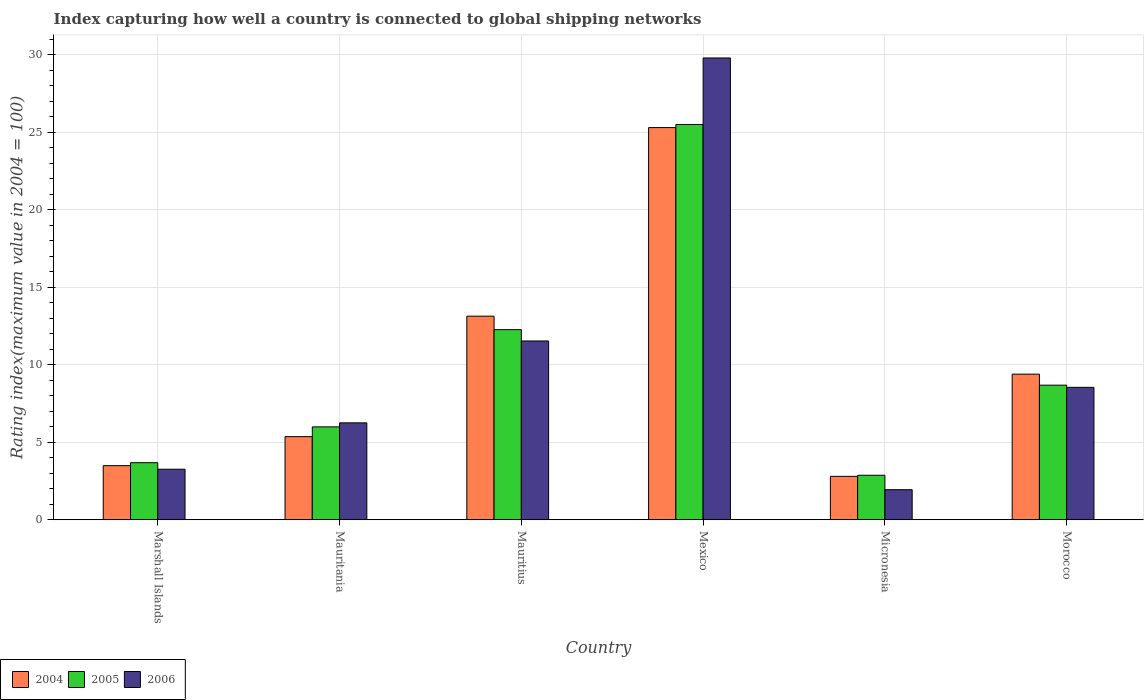How many groups of bars are there?
Make the answer very short. 6. Are the number of bars on each tick of the X-axis equal?
Make the answer very short. Yes. What is the label of the 6th group of bars from the left?
Offer a very short reply. Morocco. In how many cases, is the number of bars for a given country not equal to the number of legend labels?
Your answer should be compact. 0. What is the rating index in 2004 in Mauritania?
Your answer should be compact. 5.36. Across all countries, what is the maximum rating index in 2005?
Make the answer very short. 25.49. Across all countries, what is the minimum rating index in 2005?
Your answer should be compact. 2.87. In which country was the rating index in 2004 maximum?
Give a very brief answer. Mexico. In which country was the rating index in 2006 minimum?
Your answer should be compact. Micronesia. What is the total rating index in 2005 in the graph?
Your response must be concise. 58.97. What is the difference between the rating index in 2006 in Mexico and that in Morocco?
Ensure brevity in your answer.  21.24. What is the difference between the rating index in 2006 in Morocco and the rating index in 2004 in Micronesia?
Keep it short and to the point. 5.74. What is the average rating index in 2004 per country?
Keep it short and to the point. 9.91. What is the difference between the rating index of/in 2004 and rating index of/in 2006 in Micronesia?
Your answer should be very brief. 0.86. What is the ratio of the rating index in 2006 in Micronesia to that in Morocco?
Provide a succinct answer. 0.23. Is the rating index in 2005 in Mauritius less than that in Morocco?
Keep it short and to the point. No. Is the difference between the rating index in 2004 in Mauritania and Morocco greater than the difference between the rating index in 2006 in Mauritania and Morocco?
Ensure brevity in your answer.  No. What is the difference between the highest and the second highest rating index in 2004?
Keep it short and to the point. 12.16. What is the difference between the highest and the lowest rating index in 2004?
Make the answer very short. 22.49. In how many countries, is the rating index in 2004 greater than the average rating index in 2004 taken over all countries?
Ensure brevity in your answer.  2. Is the sum of the rating index in 2004 in Marshall Islands and Morocco greater than the maximum rating index in 2005 across all countries?
Make the answer very short. No. What does the 3rd bar from the left in Morocco represents?
Provide a succinct answer. 2006. What does the 3rd bar from the right in Mauritania represents?
Offer a very short reply. 2004. How many bars are there?
Offer a terse response. 18. What is the difference between two consecutive major ticks on the Y-axis?
Make the answer very short. 5. Does the graph contain grids?
Your response must be concise. Yes. How many legend labels are there?
Your answer should be compact. 3. What is the title of the graph?
Offer a terse response. Index capturing how well a country is connected to global shipping networks. What is the label or title of the Y-axis?
Give a very brief answer. Rating index(maximum value in 2004 = 100). What is the Rating index(maximum value in 2004 = 100) of 2004 in Marshall Islands?
Your answer should be compact. 3.49. What is the Rating index(maximum value in 2004 = 100) in 2005 in Marshall Islands?
Make the answer very short. 3.68. What is the Rating index(maximum value in 2004 = 100) in 2006 in Marshall Islands?
Provide a short and direct response. 3.26. What is the Rating index(maximum value in 2004 = 100) in 2004 in Mauritania?
Your response must be concise. 5.36. What is the Rating index(maximum value in 2004 = 100) in 2005 in Mauritania?
Ensure brevity in your answer.  5.99. What is the Rating index(maximum value in 2004 = 100) in 2006 in Mauritania?
Provide a succinct answer. 6.25. What is the Rating index(maximum value in 2004 = 100) of 2004 in Mauritius?
Your answer should be compact. 13.13. What is the Rating index(maximum value in 2004 = 100) of 2005 in Mauritius?
Your answer should be compact. 12.26. What is the Rating index(maximum value in 2004 = 100) in 2006 in Mauritius?
Your answer should be very brief. 11.53. What is the Rating index(maximum value in 2004 = 100) of 2004 in Mexico?
Your answer should be very brief. 25.29. What is the Rating index(maximum value in 2004 = 100) in 2005 in Mexico?
Ensure brevity in your answer.  25.49. What is the Rating index(maximum value in 2004 = 100) of 2006 in Mexico?
Provide a short and direct response. 29.78. What is the Rating index(maximum value in 2004 = 100) of 2005 in Micronesia?
Keep it short and to the point. 2.87. What is the Rating index(maximum value in 2004 = 100) of 2006 in Micronesia?
Your answer should be very brief. 1.94. What is the Rating index(maximum value in 2004 = 100) of 2004 in Morocco?
Ensure brevity in your answer.  9.39. What is the Rating index(maximum value in 2004 = 100) of 2005 in Morocco?
Provide a short and direct response. 8.68. What is the Rating index(maximum value in 2004 = 100) of 2006 in Morocco?
Your answer should be compact. 8.54. Across all countries, what is the maximum Rating index(maximum value in 2004 = 100) in 2004?
Give a very brief answer. 25.29. Across all countries, what is the maximum Rating index(maximum value in 2004 = 100) of 2005?
Your answer should be compact. 25.49. Across all countries, what is the maximum Rating index(maximum value in 2004 = 100) in 2006?
Offer a very short reply. 29.78. Across all countries, what is the minimum Rating index(maximum value in 2004 = 100) in 2004?
Keep it short and to the point. 2.8. Across all countries, what is the minimum Rating index(maximum value in 2004 = 100) in 2005?
Make the answer very short. 2.87. Across all countries, what is the minimum Rating index(maximum value in 2004 = 100) of 2006?
Provide a short and direct response. 1.94. What is the total Rating index(maximum value in 2004 = 100) of 2004 in the graph?
Your response must be concise. 59.46. What is the total Rating index(maximum value in 2004 = 100) of 2005 in the graph?
Give a very brief answer. 58.97. What is the total Rating index(maximum value in 2004 = 100) in 2006 in the graph?
Make the answer very short. 61.3. What is the difference between the Rating index(maximum value in 2004 = 100) of 2004 in Marshall Islands and that in Mauritania?
Your response must be concise. -1.87. What is the difference between the Rating index(maximum value in 2004 = 100) in 2005 in Marshall Islands and that in Mauritania?
Ensure brevity in your answer.  -2.31. What is the difference between the Rating index(maximum value in 2004 = 100) in 2006 in Marshall Islands and that in Mauritania?
Ensure brevity in your answer.  -2.99. What is the difference between the Rating index(maximum value in 2004 = 100) of 2004 in Marshall Islands and that in Mauritius?
Your answer should be very brief. -9.64. What is the difference between the Rating index(maximum value in 2004 = 100) in 2005 in Marshall Islands and that in Mauritius?
Offer a terse response. -8.58. What is the difference between the Rating index(maximum value in 2004 = 100) in 2006 in Marshall Islands and that in Mauritius?
Offer a terse response. -8.27. What is the difference between the Rating index(maximum value in 2004 = 100) of 2004 in Marshall Islands and that in Mexico?
Provide a succinct answer. -21.8. What is the difference between the Rating index(maximum value in 2004 = 100) in 2005 in Marshall Islands and that in Mexico?
Provide a short and direct response. -21.81. What is the difference between the Rating index(maximum value in 2004 = 100) of 2006 in Marshall Islands and that in Mexico?
Offer a terse response. -26.52. What is the difference between the Rating index(maximum value in 2004 = 100) of 2004 in Marshall Islands and that in Micronesia?
Offer a terse response. 0.69. What is the difference between the Rating index(maximum value in 2004 = 100) in 2005 in Marshall Islands and that in Micronesia?
Provide a short and direct response. 0.81. What is the difference between the Rating index(maximum value in 2004 = 100) of 2006 in Marshall Islands and that in Micronesia?
Your answer should be compact. 1.32. What is the difference between the Rating index(maximum value in 2004 = 100) of 2006 in Marshall Islands and that in Morocco?
Provide a short and direct response. -5.28. What is the difference between the Rating index(maximum value in 2004 = 100) of 2004 in Mauritania and that in Mauritius?
Offer a very short reply. -7.77. What is the difference between the Rating index(maximum value in 2004 = 100) in 2005 in Mauritania and that in Mauritius?
Give a very brief answer. -6.27. What is the difference between the Rating index(maximum value in 2004 = 100) of 2006 in Mauritania and that in Mauritius?
Offer a very short reply. -5.28. What is the difference between the Rating index(maximum value in 2004 = 100) in 2004 in Mauritania and that in Mexico?
Your response must be concise. -19.93. What is the difference between the Rating index(maximum value in 2004 = 100) in 2005 in Mauritania and that in Mexico?
Give a very brief answer. -19.5. What is the difference between the Rating index(maximum value in 2004 = 100) of 2006 in Mauritania and that in Mexico?
Provide a short and direct response. -23.53. What is the difference between the Rating index(maximum value in 2004 = 100) in 2004 in Mauritania and that in Micronesia?
Ensure brevity in your answer.  2.56. What is the difference between the Rating index(maximum value in 2004 = 100) of 2005 in Mauritania and that in Micronesia?
Provide a succinct answer. 3.12. What is the difference between the Rating index(maximum value in 2004 = 100) in 2006 in Mauritania and that in Micronesia?
Provide a short and direct response. 4.31. What is the difference between the Rating index(maximum value in 2004 = 100) in 2004 in Mauritania and that in Morocco?
Ensure brevity in your answer.  -4.03. What is the difference between the Rating index(maximum value in 2004 = 100) in 2005 in Mauritania and that in Morocco?
Offer a very short reply. -2.69. What is the difference between the Rating index(maximum value in 2004 = 100) in 2006 in Mauritania and that in Morocco?
Make the answer very short. -2.29. What is the difference between the Rating index(maximum value in 2004 = 100) of 2004 in Mauritius and that in Mexico?
Your answer should be compact. -12.16. What is the difference between the Rating index(maximum value in 2004 = 100) in 2005 in Mauritius and that in Mexico?
Ensure brevity in your answer.  -13.23. What is the difference between the Rating index(maximum value in 2004 = 100) of 2006 in Mauritius and that in Mexico?
Your response must be concise. -18.25. What is the difference between the Rating index(maximum value in 2004 = 100) in 2004 in Mauritius and that in Micronesia?
Offer a very short reply. 10.33. What is the difference between the Rating index(maximum value in 2004 = 100) in 2005 in Mauritius and that in Micronesia?
Provide a succinct answer. 9.39. What is the difference between the Rating index(maximum value in 2004 = 100) in 2006 in Mauritius and that in Micronesia?
Offer a terse response. 9.59. What is the difference between the Rating index(maximum value in 2004 = 100) of 2004 in Mauritius and that in Morocco?
Provide a succinct answer. 3.74. What is the difference between the Rating index(maximum value in 2004 = 100) of 2005 in Mauritius and that in Morocco?
Your response must be concise. 3.58. What is the difference between the Rating index(maximum value in 2004 = 100) of 2006 in Mauritius and that in Morocco?
Offer a terse response. 2.99. What is the difference between the Rating index(maximum value in 2004 = 100) of 2004 in Mexico and that in Micronesia?
Provide a short and direct response. 22.49. What is the difference between the Rating index(maximum value in 2004 = 100) in 2005 in Mexico and that in Micronesia?
Offer a very short reply. 22.62. What is the difference between the Rating index(maximum value in 2004 = 100) in 2006 in Mexico and that in Micronesia?
Your response must be concise. 27.84. What is the difference between the Rating index(maximum value in 2004 = 100) in 2004 in Mexico and that in Morocco?
Your answer should be compact. 15.9. What is the difference between the Rating index(maximum value in 2004 = 100) of 2005 in Mexico and that in Morocco?
Your answer should be compact. 16.81. What is the difference between the Rating index(maximum value in 2004 = 100) of 2006 in Mexico and that in Morocco?
Provide a succinct answer. 21.24. What is the difference between the Rating index(maximum value in 2004 = 100) of 2004 in Micronesia and that in Morocco?
Make the answer very short. -6.59. What is the difference between the Rating index(maximum value in 2004 = 100) of 2005 in Micronesia and that in Morocco?
Make the answer very short. -5.81. What is the difference between the Rating index(maximum value in 2004 = 100) of 2004 in Marshall Islands and the Rating index(maximum value in 2004 = 100) of 2005 in Mauritania?
Your response must be concise. -2.5. What is the difference between the Rating index(maximum value in 2004 = 100) of 2004 in Marshall Islands and the Rating index(maximum value in 2004 = 100) of 2006 in Mauritania?
Offer a terse response. -2.76. What is the difference between the Rating index(maximum value in 2004 = 100) of 2005 in Marshall Islands and the Rating index(maximum value in 2004 = 100) of 2006 in Mauritania?
Keep it short and to the point. -2.57. What is the difference between the Rating index(maximum value in 2004 = 100) in 2004 in Marshall Islands and the Rating index(maximum value in 2004 = 100) in 2005 in Mauritius?
Provide a short and direct response. -8.77. What is the difference between the Rating index(maximum value in 2004 = 100) in 2004 in Marshall Islands and the Rating index(maximum value in 2004 = 100) in 2006 in Mauritius?
Your response must be concise. -8.04. What is the difference between the Rating index(maximum value in 2004 = 100) in 2005 in Marshall Islands and the Rating index(maximum value in 2004 = 100) in 2006 in Mauritius?
Make the answer very short. -7.85. What is the difference between the Rating index(maximum value in 2004 = 100) in 2004 in Marshall Islands and the Rating index(maximum value in 2004 = 100) in 2006 in Mexico?
Ensure brevity in your answer.  -26.29. What is the difference between the Rating index(maximum value in 2004 = 100) of 2005 in Marshall Islands and the Rating index(maximum value in 2004 = 100) of 2006 in Mexico?
Ensure brevity in your answer.  -26.1. What is the difference between the Rating index(maximum value in 2004 = 100) of 2004 in Marshall Islands and the Rating index(maximum value in 2004 = 100) of 2005 in Micronesia?
Offer a terse response. 0.62. What is the difference between the Rating index(maximum value in 2004 = 100) of 2004 in Marshall Islands and the Rating index(maximum value in 2004 = 100) of 2006 in Micronesia?
Your response must be concise. 1.55. What is the difference between the Rating index(maximum value in 2004 = 100) in 2005 in Marshall Islands and the Rating index(maximum value in 2004 = 100) in 2006 in Micronesia?
Your answer should be very brief. 1.74. What is the difference between the Rating index(maximum value in 2004 = 100) in 2004 in Marshall Islands and the Rating index(maximum value in 2004 = 100) in 2005 in Morocco?
Provide a succinct answer. -5.19. What is the difference between the Rating index(maximum value in 2004 = 100) of 2004 in Marshall Islands and the Rating index(maximum value in 2004 = 100) of 2006 in Morocco?
Ensure brevity in your answer.  -5.05. What is the difference between the Rating index(maximum value in 2004 = 100) of 2005 in Marshall Islands and the Rating index(maximum value in 2004 = 100) of 2006 in Morocco?
Ensure brevity in your answer.  -4.86. What is the difference between the Rating index(maximum value in 2004 = 100) of 2004 in Mauritania and the Rating index(maximum value in 2004 = 100) of 2005 in Mauritius?
Your answer should be compact. -6.9. What is the difference between the Rating index(maximum value in 2004 = 100) of 2004 in Mauritania and the Rating index(maximum value in 2004 = 100) of 2006 in Mauritius?
Ensure brevity in your answer.  -6.17. What is the difference between the Rating index(maximum value in 2004 = 100) of 2005 in Mauritania and the Rating index(maximum value in 2004 = 100) of 2006 in Mauritius?
Provide a succinct answer. -5.54. What is the difference between the Rating index(maximum value in 2004 = 100) of 2004 in Mauritania and the Rating index(maximum value in 2004 = 100) of 2005 in Mexico?
Give a very brief answer. -20.13. What is the difference between the Rating index(maximum value in 2004 = 100) in 2004 in Mauritania and the Rating index(maximum value in 2004 = 100) in 2006 in Mexico?
Give a very brief answer. -24.42. What is the difference between the Rating index(maximum value in 2004 = 100) of 2005 in Mauritania and the Rating index(maximum value in 2004 = 100) of 2006 in Mexico?
Ensure brevity in your answer.  -23.79. What is the difference between the Rating index(maximum value in 2004 = 100) in 2004 in Mauritania and the Rating index(maximum value in 2004 = 100) in 2005 in Micronesia?
Offer a very short reply. 2.49. What is the difference between the Rating index(maximum value in 2004 = 100) in 2004 in Mauritania and the Rating index(maximum value in 2004 = 100) in 2006 in Micronesia?
Make the answer very short. 3.42. What is the difference between the Rating index(maximum value in 2004 = 100) in 2005 in Mauritania and the Rating index(maximum value in 2004 = 100) in 2006 in Micronesia?
Provide a succinct answer. 4.05. What is the difference between the Rating index(maximum value in 2004 = 100) of 2004 in Mauritania and the Rating index(maximum value in 2004 = 100) of 2005 in Morocco?
Your answer should be very brief. -3.32. What is the difference between the Rating index(maximum value in 2004 = 100) in 2004 in Mauritania and the Rating index(maximum value in 2004 = 100) in 2006 in Morocco?
Offer a terse response. -3.18. What is the difference between the Rating index(maximum value in 2004 = 100) of 2005 in Mauritania and the Rating index(maximum value in 2004 = 100) of 2006 in Morocco?
Your answer should be compact. -2.55. What is the difference between the Rating index(maximum value in 2004 = 100) in 2004 in Mauritius and the Rating index(maximum value in 2004 = 100) in 2005 in Mexico?
Your answer should be compact. -12.36. What is the difference between the Rating index(maximum value in 2004 = 100) in 2004 in Mauritius and the Rating index(maximum value in 2004 = 100) in 2006 in Mexico?
Offer a terse response. -16.65. What is the difference between the Rating index(maximum value in 2004 = 100) of 2005 in Mauritius and the Rating index(maximum value in 2004 = 100) of 2006 in Mexico?
Provide a short and direct response. -17.52. What is the difference between the Rating index(maximum value in 2004 = 100) of 2004 in Mauritius and the Rating index(maximum value in 2004 = 100) of 2005 in Micronesia?
Give a very brief answer. 10.26. What is the difference between the Rating index(maximum value in 2004 = 100) of 2004 in Mauritius and the Rating index(maximum value in 2004 = 100) of 2006 in Micronesia?
Keep it short and to the point. 11.19. What is the difference between the Rating index(maximum value in 2004 = 100) of 2005 in Mauritius and the Rating index(maximum value in 2004 = 100) of 2006 in Micronesia?
Keep it short and to the point. 10.32. What is the difference between the Rating index(maximum value in 2004 = 100) of 2004 in Mauritius and the Rating index(maximum value in 2004 = 100) of 2005 in Morocco?
Make the answer very short. 4.45. What is the difference between the Rating index(maximum value in 2004 = 100) in 2004 in Mauritius and the Rating index(maximum value in 2004 = 100) in 2006 in Morocco?
Ensure brevity in your answer.  4.59. What is the difference between the Rating index(maximum value in 2004 = 100) in 2005 in Mauritius and the Rating index(maximum value in 2004 = 100) in 2006 in Morocco?
Offer a terse response. 3.72. What is the difference between the Rating index(maximum value in 2004 = 100) in 2004 in Mexico and the Rating index(maximum value in 2004 = 100) in 2005 in Micronesia?
Provide a succinct answer. 22.42. What is the difference between the Rating index(maximum value in 2004 = 100) in 2004 in Mexico and the Rating index(maximum value in 2004 = 100) in 2006 in Micronesia?
Your answer should be compact. 23.35. What is the difference between the Rating index(maximum value in 2004 = 100) of 2005 in Mexico and the Rating index(maximum value in 2004 = 100) of 2006 in Micronesia?
Ensure brevity in your answer.  23.55. What is the difference between the Rating index(maximum value in 2004 = 100) of 2004 in Mexico and the Rating index(maximum value in 2004 = 100) of 2005 in Morocco?
Offer a very short reply. 16.61. What is the difference between the Rating index(maximum value in 2004 = 100) in 2004 in Mexico and the Rating index(maximum value in 2004 = 100) in 2006 in Morocco?
Your answer should be compact. 16.75. What is the difference between the Rating index(maximum value in 2004 = 100) of 2005 in Mexico and the Rating index(maximum value in 2004 = 100) of 2006 in Morocco?
Your response must be concise. 16.95. What is the difference between the Rating index(maximum value in 2004 = 100) in 2004 in Micronesia and the Rating index(maximum value in 2004 = 100) in 2005 in Morocco?
Offer a terse response. -5.88. What is the difference between the Rating index(maximum value in 2004 = 100) of 2004 in Micronesia and the Rating index(maximum value in 2004 = 100) of 2006 in Morocco?
Your answer should be very brief. -5.74. What is the difference between the Rating index(maximum value in 2004 = 100) of 2005 in Micronesia and the Rating index(maximum value in 2004 = 100) of 2006 in Morocco?
Give a very brief answer. -5.67. What is the average Rating index(maximum value in 2004 = 100) in 2004 per country?
Offer a very short reply. 9.91. What is the average Rating index(maximum value in 2004 = 100) in 2005 per country?
Make the answer very short. 9.83. What is the average Rating index(maximum value in 2004 = 100) in 2006 per country?
Keep it short and to the point. 10.22. What is the difference between the Rating index(maximum value in 2004 = 100) of 2004 and Rating index(maximum value in 2004 = 100) of 2005 in Marshall Islands?
Ensure brevity in your answer.  -0.19. What is the difference between the Rating index(maximum value in 2004 = 100) in 2004 and Rating index(maximum value in 2004 = 100) in 2006 in Marshall Islands?
Provide a succinct answer. 0.23. What is the difference between the Rating index(maximum value in 2004 = 100) of 2005 and Rating index(maximum value in 2004 = 100) of 2006 in Marshall Islands?
Your answer should be compact. 0.42. What is the difference between the Rating index(maximum value in 2004 = 100) in 2004 and Rating index(maximum value in 2004 = 100) in 2005 in Mauritania?
Ensure brevity in your answer.  -0.63. What is the difference between the Rating index(maximum value in 2004 = 100) in 2004 and Rating index(maximum value in 2004 = 100) in 2006 in Mauritania?
Provide a short and direct response. -0.89. What is the difference between the Rating index(maximum value in 2004 = 100) in 2005 and Rating index(maximum value in 2004 = 100) in 2006 in Mauritania?
Your answer should be very brief. -0.26. What is the difference between the Rating index(maximum value in 2004 = 100) of 2004 and Rating index(maximum value in 2004 = 100) of 2005 in Mauritius?
Your answer should be very brief. 0.87. What is the difference between the Rating index(maximum value in 2004 = 100) in 2004 and Rating index(maximum value in 2004 = 100) in 2006 in Mauritius?
Provide a short and direct response. 1.6. What is the difference between the Rating index(maximum value in 2004 = 100) of 2005 and Rating index(maximum value in 2004 = 100) of 2006 in Mauritius?
Provide a short and direct response. 0.73. What is the difference between the Rating index(maximum value in 2004 = 100) in 2004 and Rating index(maximum value in 2004 = 100) in 2006 in Mexico?
Keep it short and to the point. -4.49. What is the difference between the Rating index(maximum value in 2004 = 100) of 2005 and Rating index(maximum value in 2004 = 100) of 2006 in Mexico?
Provide a short and direct response. -4.29. What is the difference between the Rating index(maximum value in 2004 = 100) in 2004 and Rating index(maximum value in 2004 = 100) in 2005 in Micronesia?
Your answer should be very brief. -0.07. What is the difference between the Rating index(maximum value in 2004 = 100) of 2004 and Rating index(maximum value in 2004 = 100) of 2006 in Micronesia?
Provide a succinct answer. 0.86. What is the difference between the Rating index(maximum value in 2004 = 100) of 2004 and Rating index(maximum value in 2004 = 100) of 2005 in Morocco?
Offer a very short reply. 0.71. What is the difference between the Rating index(maximum value in 2004 = 100) in 2004 and Rating index(maximum value in 2004 = 100) in 2006 in Morocco?
Make the answer very short. 0.85. What is the difference between the Rating index(maximum value in 2004 = 100) in 2005 and Rating index(maximum value in 2004 = 100) in 2006 in Morocco?
Provide a short and direct response. 0.14. What is the ratio of the Rating index(maximum value in 2004 = 100) in 2004 in Marshall Islands to that in Mauritania?
Ensure brevity in your answer.  0.65. What is the ratio of the Rating index(maximum value in 2004 = 100) in 2005 in Marshall Islands to that in Mauritania?
Provide a short and direct response. 0.61. What is the ratio of the Rating index(maximum value in 2004 = 100) in 2006 in Marshall Islands to that in Mauritania?
Provide a succinct answer. 0.52. What is the ratio of the Rating index(maximum value in 2004 = 100) of 2004 in Marshall Islands to that in Mauritius?
Offer a terse response. 0.27. What is the ratio of the Rating index(maximum value in 2004 = 100) of 2005 in Marshall Islands to that in Mauritius?
Your response must be concise. 0.3. What is the ratio of the Rating index(maximum value in 2004 = 100) in 2006 in Marshall Islands to that in Mauritius?
Offer a terse response. 0.28. What is the ratio of the Rating index(maximum value in 2004 = 100) in 2004 in Marshall Islands to that in Mexico?
Give a very brief answer. 0.14. What is the ratio of the Rating index(maximum value in 2004 = 100) of 2005 in Marshall Islands to that in Mexico?
Ensure brevity in your answer.  0.14. What is the ratio of the Rating index(maximum value in 2004 = 100) in 2006 in Marshall Islands to that in Mexico?
Keep it short and to the point. 0.11. What is the ratio of the Rating index(maximum value in 2004 = 100) in 2004 in Marshall Islands to that in Micronesia?
Give a very brief answer. 1.25. What is the ratio of the Rating index(maximum value in 2004 = 100) in 2005 in Marshall Islands to that in Micronesia?
Offer a terse response. 1.28. What is the ratio of the Rating index(maximum value in 2004 = 100) in 2006 in Marshall Islands to that in Micronesia?
Ensure brevity in your answer.  1.68. What is the ratio of the Rating index(maximum value in 2004 = 100) of 2004 in Marshall Islands to that in Morocco?
Offer a terse response. 0.37. What is the ratio of the Rating index(maximum value in 2004 = 100) of 2005 in Marshall Islands to that in Morocco?
Offer a very short reply. 0.42. What is the ratio of the Rating index(maximum value in 2004 = 100) of 2006 in Marshall Islands to that in Morocco?
Make the answer very short. 0.38. What is the ratio of the Rating index(maximum value in 2004 = 100) of 2004 in Mauritania to that in Mauritius?
Your answer should be compact. 0.41. What is the ratio of the Rating index(maximum value in 2004 = 100) of 2005 in Mauritania to that in Mauritius?
Keep it short and to the point. 0.49. What is the ratio of the Rating index(maximum value in 2004 = 100) in 2006 in Mauritania to that in Mauritius?
Ensure brevity in your answer.  0.54. What is the ratio of the Rating index(maximum value in 2004 = 100) of 2004 in Mauritania to that in Mexico?
Your answer should be very brief. 0.21. What is the ratio of the Rating index(maximum value in 2004 = 100) of 2005 in Mauritania to that in Mexico?
Give a very brief answer. 0.23. What is the ratio of the Rating index(maximum value in 2004 = 100) of 2006 in Mauritania to that in Mexico?
Provide a succinct answer. 0.21. What is the ratio of the Rating index(maximum value in 2004 = 100) of 2004 in Mauritania to that in Micronesia?
Your answer should be very brief. 1.91. What is the ratio of the Rating index(maximum value in 2004 = 100) of 2005 in Mauritania to that in Micronesia?
Provide a succinct answer. 2.09. What is the ratio of the Rating index(maximum value in 2004 = 100) of 2006 in Mauritania to that in Micronesia?
Your answer should be very brief. 3.22. What is the ratio of the Rating index(maximum value in 2004 = 100) of 2004 in Mauritania to that in Morocco?
Offer a terse response. 0.57. What is the ratio of the Rating index(maximum value in 2004 = 100) of 2005 in Mauritania to that in Morocco?
Make the answer very short. 0.69. What is the ratio of the Rating index(maximum value in 2004 = 100) in 2006 in Mauritania to that in Morocco?
Keep it short and to the point. 0.73. What is the ratio of the Rating index(maximum value in 2004 = 100) of 2004 in Mauritius to that in Mexico?
Provide a succinct answer. 0.52. What is the ratio of the Rating index(maximum value in 2004 = 100) of 2005 in Mauritius to that in Mexico?
Offer a very short reply. 0.48. What is the ratio of the Rating index(maximum value in 2004 = 100) of 2006 in Mauritius to that in Mexico?
Your response must be concise. 0.39. What is the ratio of the Rating index(maximum value in 2004 = 100) in 2004 in Mauritius to that in Micronesia?
Offer a very short reply. 4.69. What is the ratio of the Rating index(maximum value in 2004 = 100) in 2005 in Mauritius to that in Micronesia?
Offer a terse response. 4.27. What is the ratio of the Rating index(maximum value in 2004 = 100) of 2006 in Mauritius to that in Micronesia?
Ensure brevity in your answer.  5.94. What is the ratio of the Rating index(maximum value in 2004 = 100) of 2004 in Mauritius to that in Morocco?
Your response must be concise. 1.4. What is the ratio of the Rating index(maximum value in 2004 = 100) of 2005 in Mauritius to that in Morocco?
Ensure brevity in your answer.  1.41. What is the ratio of the Rating index(maximum value in 2004 = 100) in 2006 in Mauritius to that in Morocco?
Provide a succinct answer. 1.35. What is the ratio of the Rating index(maximum value in 2004 = 100) in 2004 in Mexico to that in Micronesia?
Give a very brief answer. 9.03. What is the ratio of the Rating index(maximum value in 2004 = 100) in 2005 in Mexico to that in Micronesia?
Your answer should be very brief. 8.88. What is the ratio of the Rating index(maximum value in 2004 = 100) in 2006 in Mexico to that in Micronesia?
Keep it short and to the point. 15.35. What is the ratio of the Rating index(maximum value in 2004 = 100) of 2004 in Mexico to that in Morocco?
Offer a terse response. 2.69. What is the ratio of the Rating index(maximum value in 2004 = 100) in 2005 in Mexico to that in Morocco?
Offer a very short reply. 2.94. What is the ratio of the Rating index(maximum value in 2004 = 100) in 2006 in Mexico to that in Morocco?
Keep it short and to the point. 3.49. What is the ratio of the Rating index(maximum value in 2004 = 100) in 2004 in Micronesia to that in Morocco?
Your answer should be very brief. 0.3. What is the ratio of the Rating index(maximum value in 2004 = 100) in 2005 in Micronesia to that in Morocco?
Your answer should be compact. 0.33. What is the ratio of the Rating index(maximum value in 2004 = 100) in 2006 in Micronesia to that in Morocco?
Your response must be concise. 0.23. What is the difference between the highest and the second highest Rating index(maximum value in 2004 = 100) in 2004?
Ensure brevity in your answer.  12.16. What is the difference between the highest and the second highest Rating index(maximum value in 2004 = 100) in 2005?
Your answer should be very brief. 13.23. What is the difference between the highest and the second highest Rating index(maximum value in 2004 = 100) in 2006?
Offer a very short reply. 18.25. What is the difference between the highest and the lowest Rating index(maximum value in 2004 = 100) of 2004?
Give a very brief answer. 22.49. What is the difference between the highest and the lowest Rating index(maximum value in 2004 = 100) in 2005?
Keep it short and to the point. 22.62. What is the difference between the highest and the lowest Rating index(maximum value in 2004 = 100) in 2006?
Give a very brief answer. 27.84. 